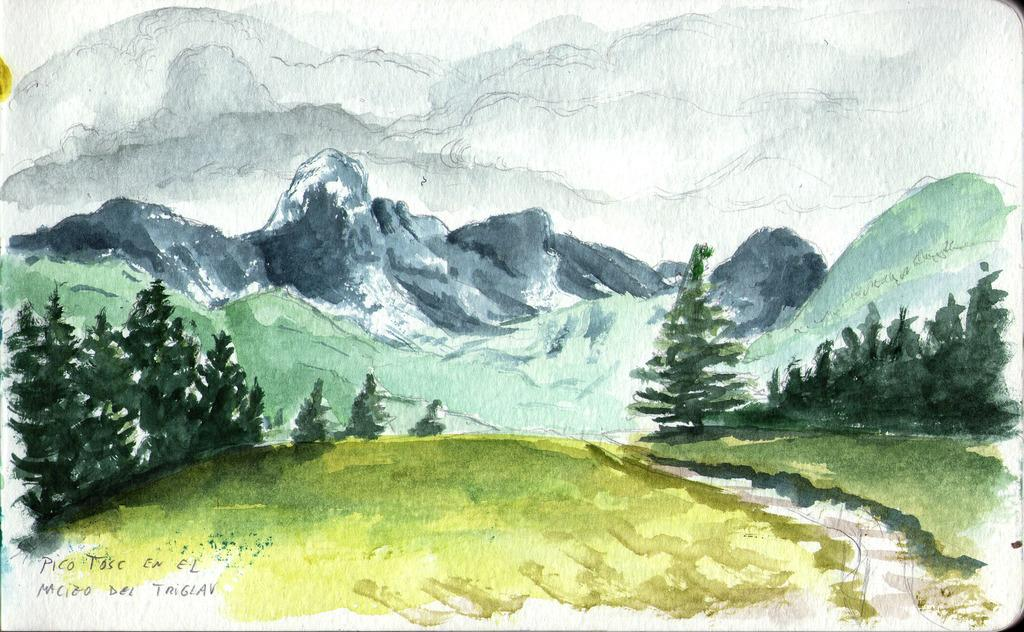What is the main subject of the painting in the image? The painting in the image depicts trees, mountains, and the sky. Can you describe the landscape depicted in the painting? The painting depicts a landscape with trees, mountains, and the sky. Is there any text present in the image? Yes, there is some text in the bottom left side of the image. How many breaths can be counted in the image? There are no breaths present in the image, as it is a painting of a landscape. 